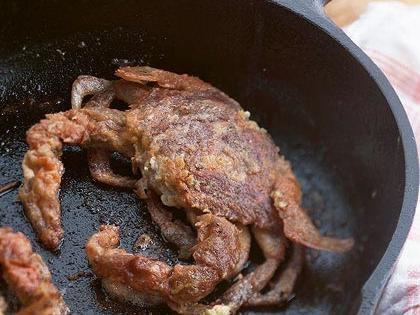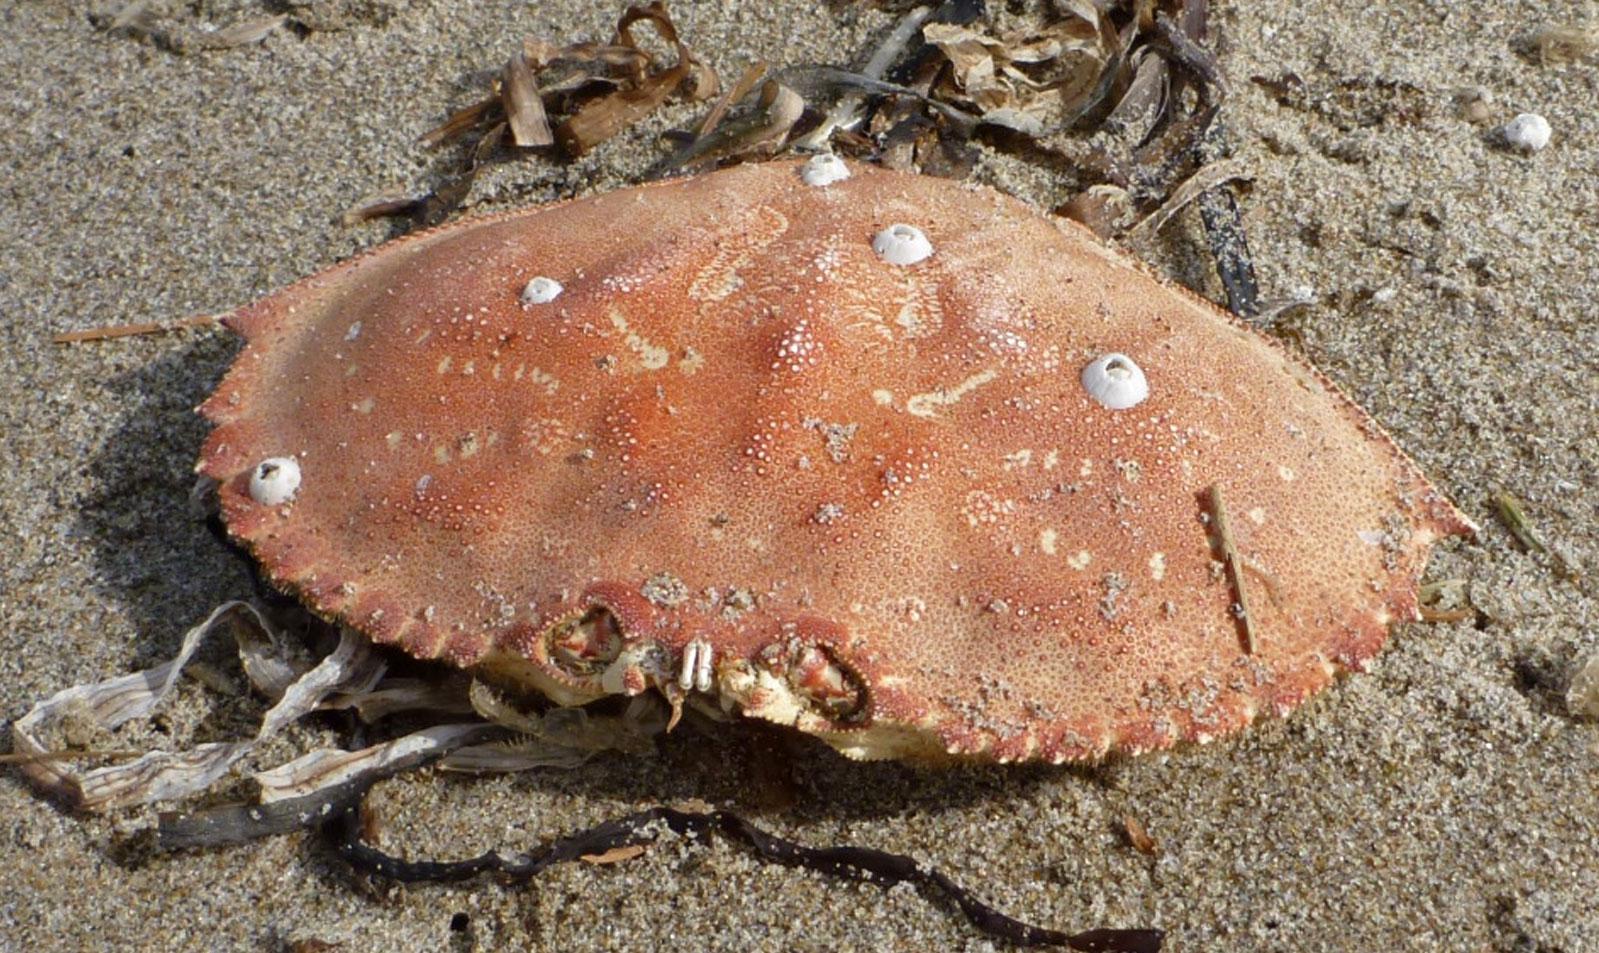The first image is the image on the left, the second image is the image on the right. Assess this claim about the two images: "there are two crab sheels on the sand in the image pair". Correct or not? Answer yes or no. No. The first image is the image on the left, the second image is the image on the right. Analyze the images presented: Is the assertion "Each crab sits on a sandy surface." valid? Answer yes or no. No. 